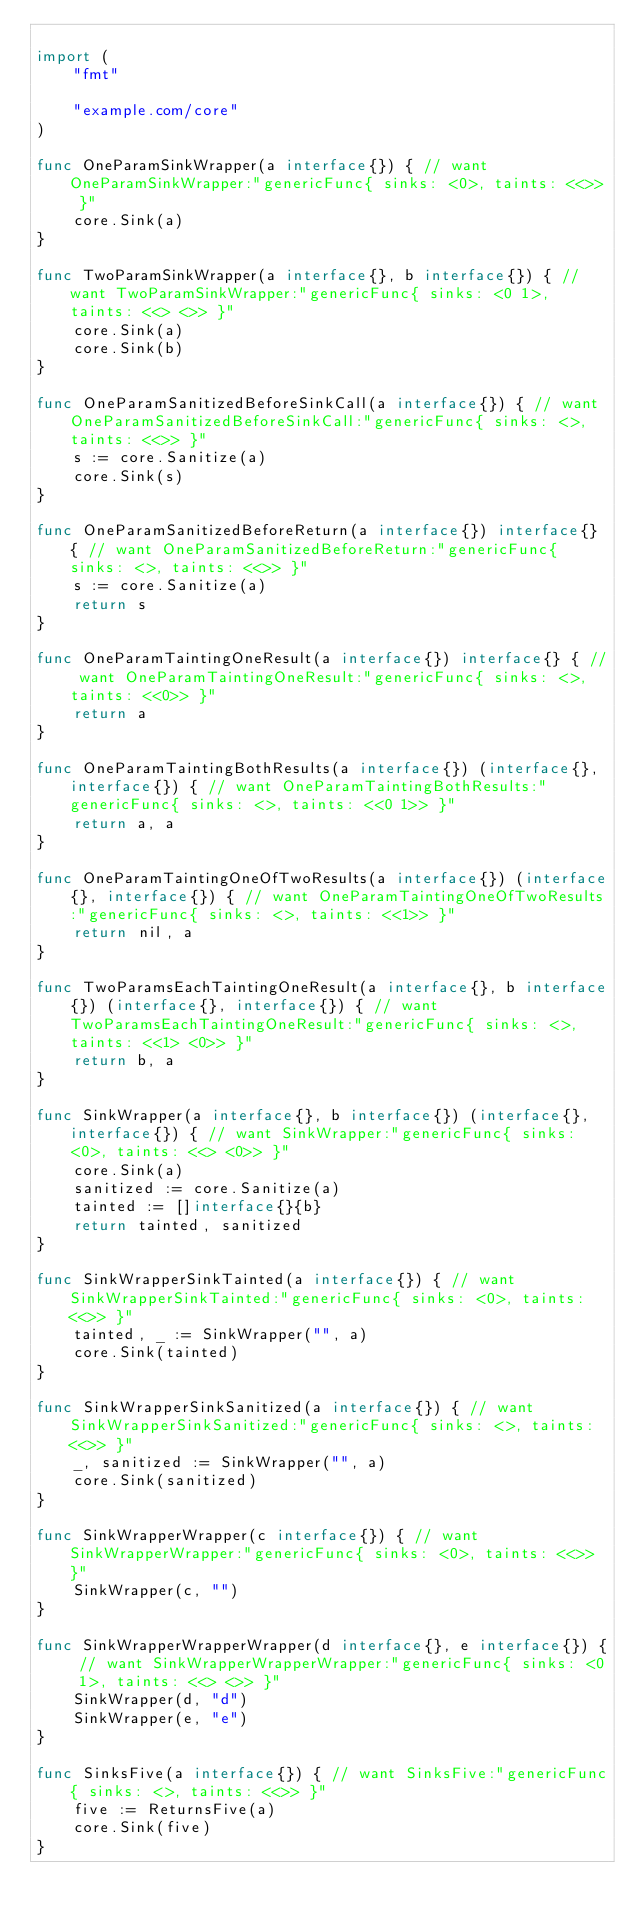<code> <loc_0><loc_0><loc_500><loc_500><_Go_>
import (
	"fmt"

	"example.com/core"
)

func OneParamSinkWrapper(a interface{}) { // want OneParamSinkWrapper:"genericFunc{ sinks: <0>, taints: <<>> }"
	core.Sink(a)
}

func TwoParamSinkWrapper(a interface{}, b interface{}) { // want TwoParamSinkWrapper:"genericFunc{ sinks: <0 1>, taints: <<> <>> }"
	core.Sink(a)
	core.Sink(b)
}

func OneParamSanitizedBeforeSinkCall(a interface{}) { // want OneParamSanitizedBeforeSinkCall:"genericFunc{ sinks: <>, taints: <<>> }"
	s := core.Sanitize(a)
	core.Sink(s)
}

func OneParamSanitizedBeforeReturn(a interface{}) interface{} { // want OneParamSanitizedBeforeReturn:"genericFunc{ sinks: <>, taints: <<>> }"
	s := core.Sanitize(a)
	return s
}

func OneParamTaintingOneResult(a interface{}) interface{} { // want OneParamTaintingOneResult:"genericFunc{ sinks: <>, taints: <<0>> }"
	return a
}

func OneParamTaintingBothResults(a interface{}) (interface{}, interface{}) { // want OneParamTaintingBothResults:"genericFunc{ sinks: <>, taints: <<0 1>> }"
	return a, a
}

func OneParamTaintingOneOfTwoResults(a interface{}) (interface{}, interface{}) { // want OneParamTaintingOneOfTwoResults:"genericFunc{ sinks: <>, taints: <<1>> }"
	return nil, a
}

func TwoParamsEachTaintingOneResult(a interface{}, b interface{}) (interface{}, interface{}) { // want TwoParamsEachTaintingOneResult:"genericFunc{ sinks: <>, taints: <<1> <0>> }"
	return b, a
}

func SinkWrapper(a interface{}, b interface{}) (interface{}, interface{}) { // want SinkWrapper:"genericFunc{ sinks: <0>, taints: <<> <0>> }"
	core.Sink(a)
	sanitized := core.Sanitize(a)
	tainted := []interface{}{b}
	return tainted, sanitized
}

func SinkWrapperSinkTainted(a interface{}) { // want SinkWrapperSinkTainted:"genericFunc{ sinks: <0>, taints: <<>> }"
	tainted, _ := SinkWrapper("", a)
	core.Sink(tainted)
}

func SinkWrapperSinkSanitized(a interface{}) { // want SinkWrapperSinkSanitized:"genericFunc{ sinks: <>, taints: <<>> }"
	_, sanitized := SinkWrapper("", a)
	core.Sink(sanitized)
}

func SinkWrapperWrapper(c interface{}) { // want SinkWrapperWrapper:"genericFunc{ sinks: <0>, taints: <<>> }"
	SinkWrapper(c, "")
}

func SinkWrapperWrapperWrapper(d interface{}, e interface{}) { // want SinkWrapperWrapperWrapper:"genericFunc{ sinks: <0 1>, taints: <<> <>> }"
	SinkWrapper(d, "d")
	SinkWrapper(e, "e")
}

func SinksFive(a interface{}) { // want SinksFive:"genericFunc{ sinks: <>, taints: <<>> }"
	five := ReturnsFive(a)
	core.Sink(five)
}
</code> 